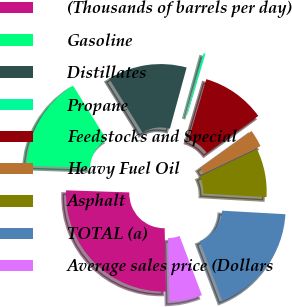Convert chart to OTSL. <chart><loc_0><loc_0><loc_500><loc_500><pie_chart><fcel>(Thousands of barrels per day)<fcel>Gasoline<fcel>Distillates<fcel>Propane<fcel>Feedstocks and Special<fcel>Heavy Fuel Oil<fcel>Asphalt<fcel>TOTAL (a)<fcel>Average sales price (Dollars<nl><fcel>25.86%<fcel>15.64%<fcel>13.08%<fcel>0.3%<fcel>10.52%<fcel>2.85%<fcel>7.97%<fcel>18.37%<fcel>5.41%<nl></chart> 